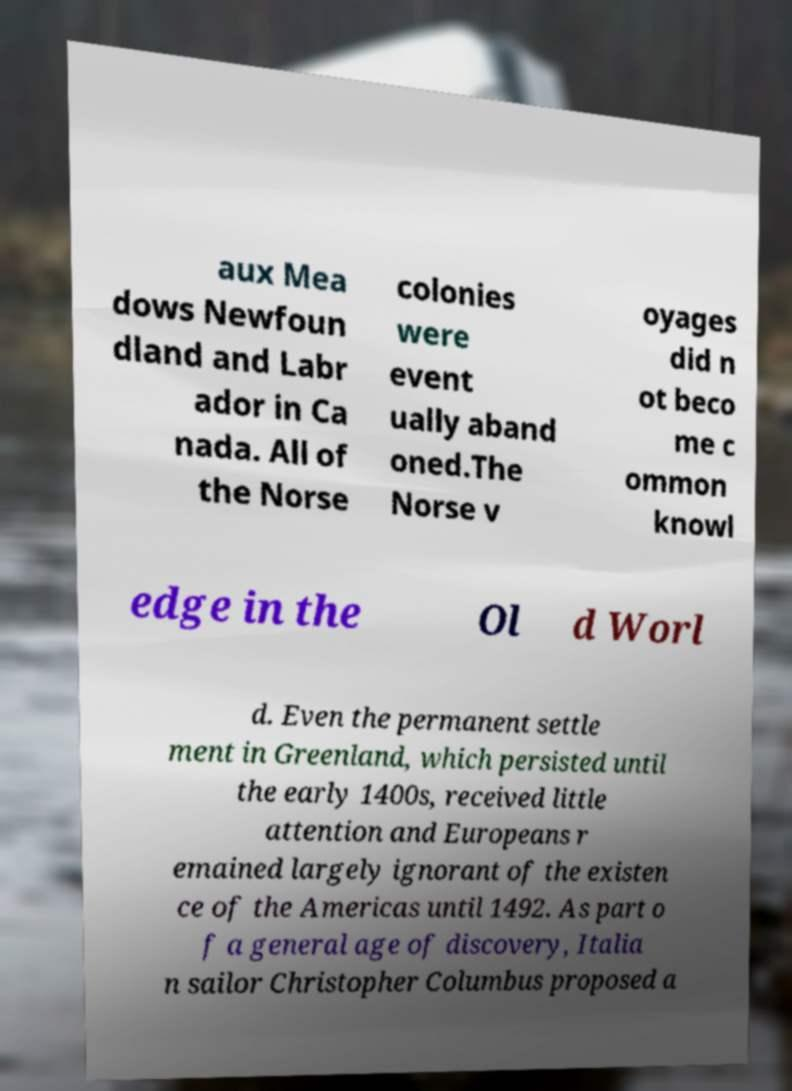Please identify and transcribe the text found in this image. aux Mea dows Newfoun dland and Labr ador in Ca nada. All of the Norse colonies were event ually aband oned.The Norse v oyages did n ot beco me c ommon knowl edge in the Ol d Worl d. Even the permanent settle ment in Greenland, which persisted until the early 1400s, received little attention and Europeans r emained largely ignorant of the existen ce of the Americas until 1492. As part o f a general age of discovery, Italia n sailor Christopher Columbus proposed a 